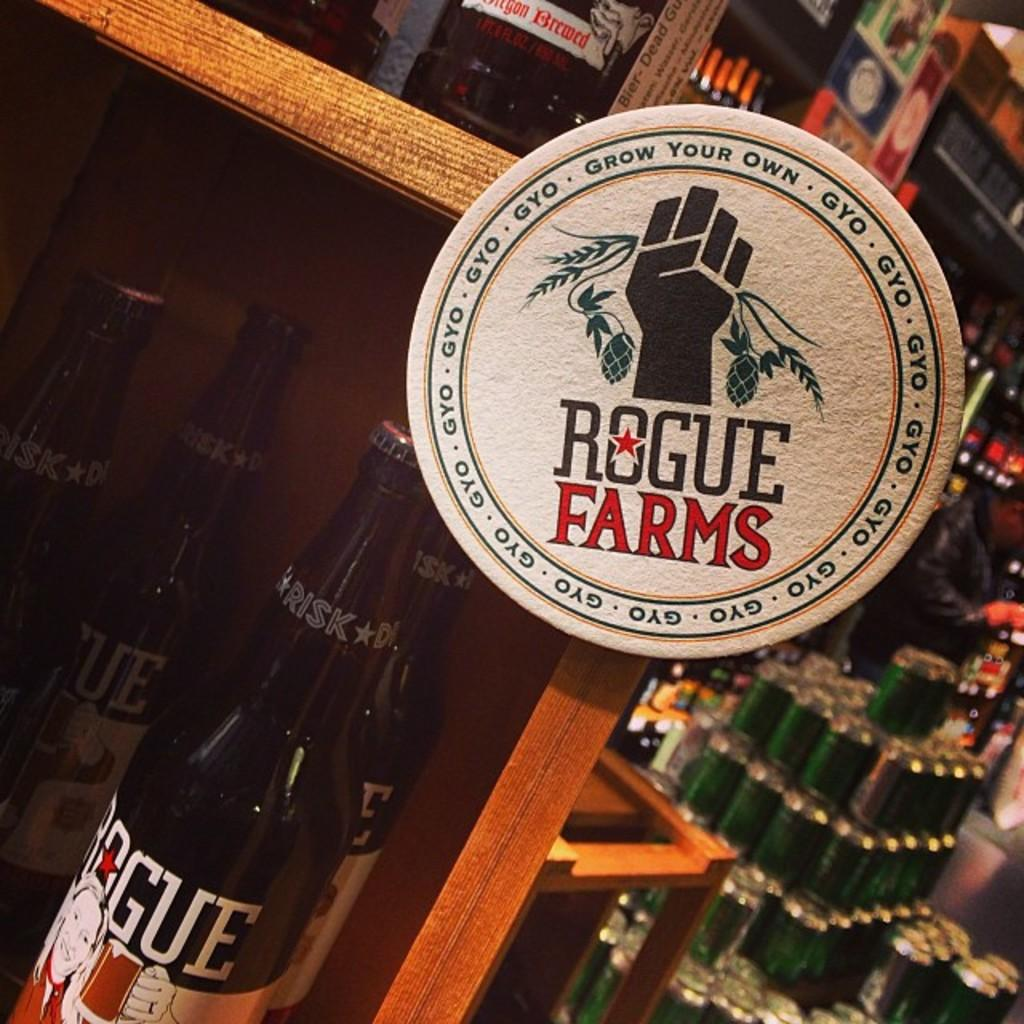Provide a one-sentence caption for the provided image. A bottle is on a shelf with a logo for Rogue Farms above it. 